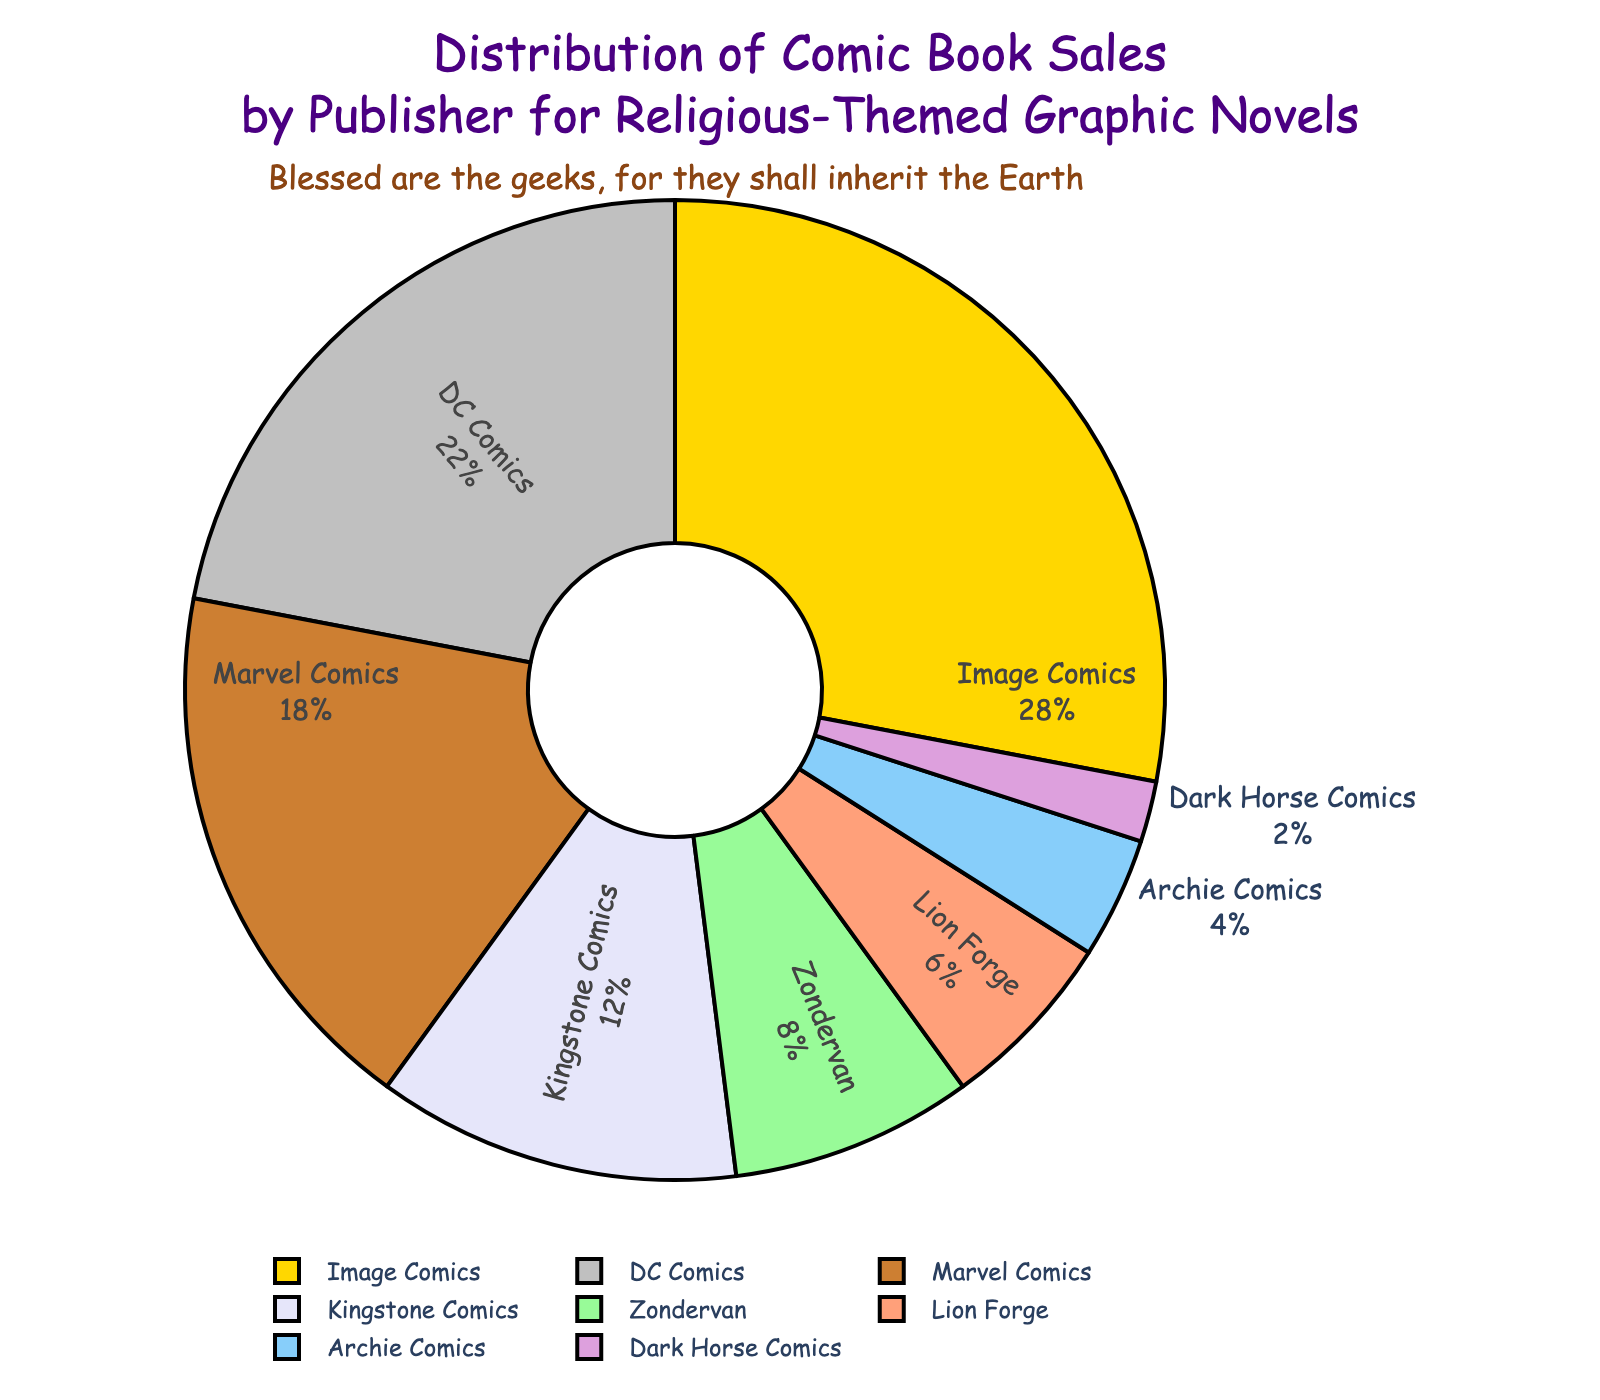What's the title of the pie chart? The title of the pie chart is displayed at the top center of the figure, typically in larger and stylized font. It reads, "Distribution of Comic Book Sales by Publisher for Religious-Themed Graphic Novels"
Answer: Distribution of Comic Book Sales by Publisher for Religious-Themed Graphic Novels Which publisher has the smallest percentage of sales? By examining the slices of the pie chart, you can see that the smallest segment corresponds to Dark Horse Comics.
Answer: Dark Horse Comics What percentage of sales does Marvel Comics account for? Look at the segment of the pie chart labeled with "Marvel Comics." The associated percentage value is shown next to the label.
Answer: 18% Is the total sales percentage of DC Comics and Image Comics greater than 50%? Add the sales percentages for DC Comics (22%) and Image Comics (28%). The sum is 22% + 28% = 50%, which is exactly 50%.
Answer: No, it's exactly 50% What is the combined sales percentage of Kingstone Comics, Zondervan, and Lion Forge? Sum the sales percentages for Kingstone Comics (12%), Zondervan (8%), and Lion Forge (6%). The total is 12% + 8% + 6% = 26%.
Answer: 26% Compare the sales percentages of Zondervan and Lion Forge. Which has a higher percentage? Examine the slices labeled "Zondervan" and "Lion Forge." Zondervan's percentage is 8%, while Lion Forge's is 6%, so Zondervan has the higher percentage.
Answer: Zondervan How does the color of the Dark Horse Comics segment differ from that of Image Comics? The slice for Dark Horse Comics is colored more towards the purple end (light violet), whereas Image Comics is depicted in gold, providing a clear differentiation in color.
Answer: Dark Horse Comics uses a light violet color, and Image Comics is gold How many publishers are represented in the pie chart? Count the labels around the pie chart corresponding to each segment. There are eight distinct labels, indicating eight publishers.
Answer: Eight publishers Which publisher has a lower sales percentage: Archie Comics or Dark Horse Comics? Observe the segments for Archie Comics and Dark Horse Comics. Archie Comics has a sales percentage of 4%, while Dark Horse Comics has 2%. Therefore, Dark Horse Comics has a lower sales percentage.
Answer: Dark Horse Comics What fraction of the chart is represented by Image Comics? The segment labeled "Image Comics" occupies 28% of the pie chart. Converting this percentage to a fraction, we get 28/100, which can be simplified to 7/25.
Answer: 7/25 